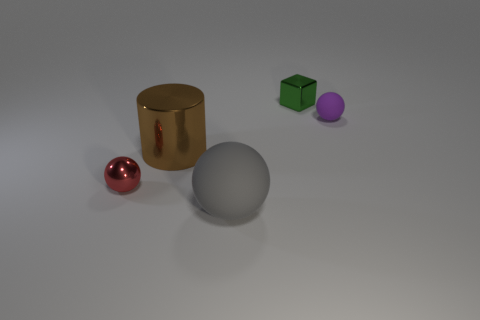Are there any spheres left of the cylinder?
Provide a short and direct response. Yes. There is a matte object that is in front of the small ball that is in front of the rubber thing behind the gray rubber ball; what color is it?
Offer a terse response. Gray. How many tiny spheres are both to the left of the brown cylinder and on the right side of the shiny ball?
Your answer should be compact. 0. How many spheres are either brown metallic objects or tiny red objects?
Make the answer very short. 1. Are there any cyan matte cylinders?
Provide a succinct answer. No. How many other objects are there of the same material as the red thing?
Ensure brevity in your answer.  2. There is a block that is the same size as the purple object; what material is it?
Keep it short and to the point. Metal. There is a rubber thing that is on the right side of the green metal thing; does it have the same shape as the brown thing?
Make the answer very short. No. Is the color of the big matte sphere the same as the shiny sphere?
Keep it short and to the point. No. How many things are either things left of the gray rubber sphere or small rubber balls?
Provide a short and direct response. 3. 